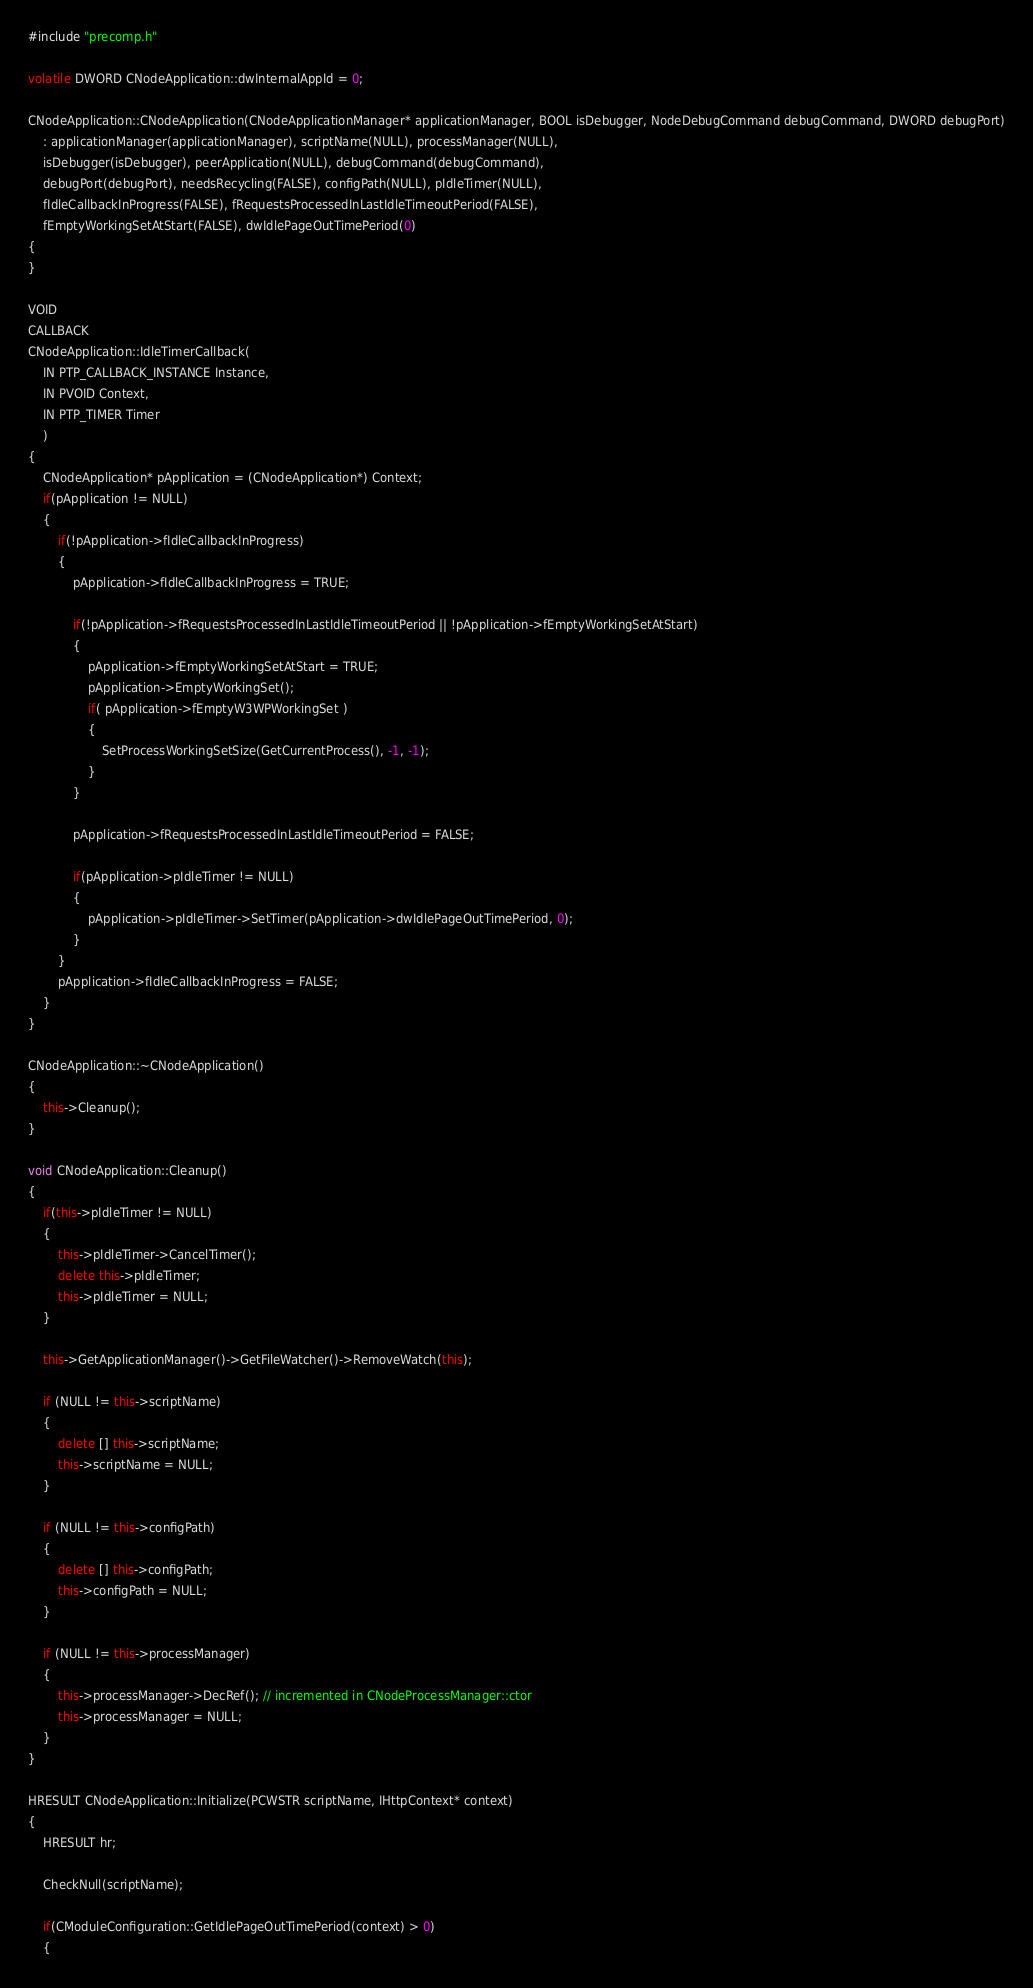Convert code to text. <code><loc_0><loc_0><loc_500><loc_500><_C++_>#include "precomp.h"

volatile DWORD CNodeApplication::dwInternalAppId = 0;

CNodeApplication::CNodeApplication(CNodeApplicationManager* applicationManager, BOOL isDebugger, NodeDebugCommand debugCommand, DWORD debugPort)
    : applicationManager(applicationManager), scriptName(NULL), processManager(NULL),
    isDebugger(isDebugger), peerApplication(NULL), debugCommand(debugCommand), 
    debugPort(debugPort), needsRecycling(FALSE), configPath(NULL), pIdleTimer(NULL), 
    fIdleCallbackInProgress(FALSE), fRequestsProcessedInLastIdleTimeoutPeriod(FALSE), 
    fEmptyWorkingSetAtStart(FALSE), dwIdlePageOutTimePeriod(0)
{
}

VOID
CALLBACK
CNodeApplication::IdleTimerCallback(
    IN PTP_CALLBACK_INSTANCE Instance,
    IN PVOID Context,
    IN PTP_TIMER Timer
    )
{
    CNodeApplication* pApplication = (CNodeApplication*) Context;
    if(pApplication != NULL)
    {
        if(!pApplication->fIdleCallbackInProgress)
        {
            pApplication->fIdleCallbackInProgress = TRUE;

            if(!pApplication->fRequestsProcessedInLastIdleTimeoutPeriod || !pApplication->fEmptyWorkingSetAtStart)
            {
                pApplication->fEmptyWorkingSetAtStart = TRUE;
                pApplication->EmptyWorkingSet();
                if( pApplication->fEmptyW3WPWorkingSet )
                {
                    SetProcessWorkingSetSize(GetCurrentProcess(), -1, -1);
                }
            }

            pApplication->fRequestsProcessedInLastIdleTimeoutPeriod = FALSE;

            if(pApplication->pIdleTimer != NULL)
            {
                pApplication->pIdleTimer->SetTimer(pApplication->dwIdlePageOutTimePeriod, 0);
            }
        }
        pApplication->fIdleCallbackInProgress = FALSE;
    }
}

CNodeApplication::~CNodeApplication()
{
    this->Cleanup();
}

void CNodeApplication::Cleanup()
{
    if(this->pIdleTimer != NULL)
    {
        this->pIdleTimer->CancelTimer();
        delete this->pIdleTimer;
        this->pIdleTimer = NULL;
    }

    this->GetApplicationManager()->GetFileWatcher()->RemoveWatch(this);

    if (NULL != this->scriptName)
    {
        delete [] this->scriptName;
        this->scriptName = NULL;
    }

    if (NULL != this->configPath)
    {
        delete [] this->configPath;
        this->configPath = NULL;
    }

    if (NULL != this->processManager)
    {
        this->processManager->DecRef(); // incremented in CNodeProcessManager::ctor
        this->processManager = NULL;
    }
}

HRESULT CNodeApplication::Initialize(PCWSTR scriptName, IHttpContext* context)
{
    HRESULT hr;

    CheckNull(scriptName);

    if(CModuleConfiguration::GetIdlePageOutTimePeriod(context) > 0)
    {</code> 